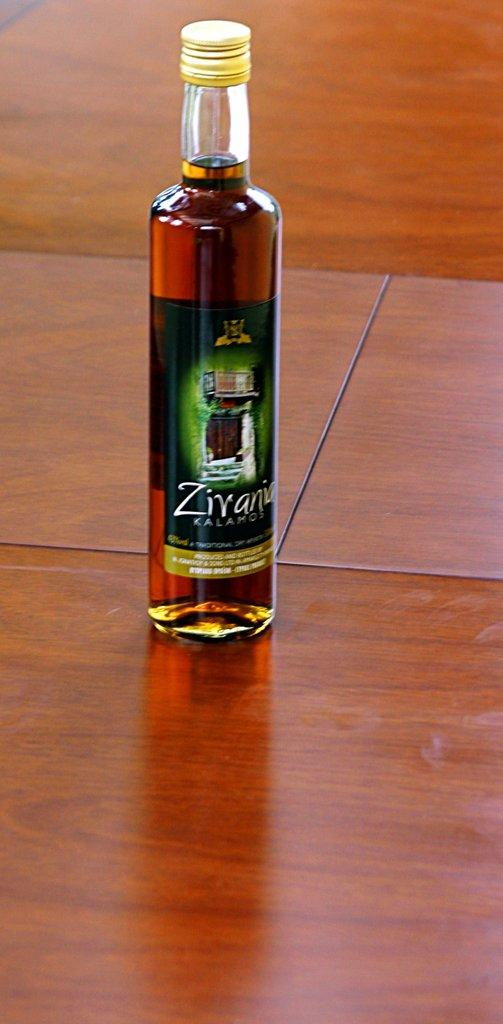<image>
Give a short and clear explanation of the subsequent image. An unopened bottle of Zivania Kalamos on a green label. 